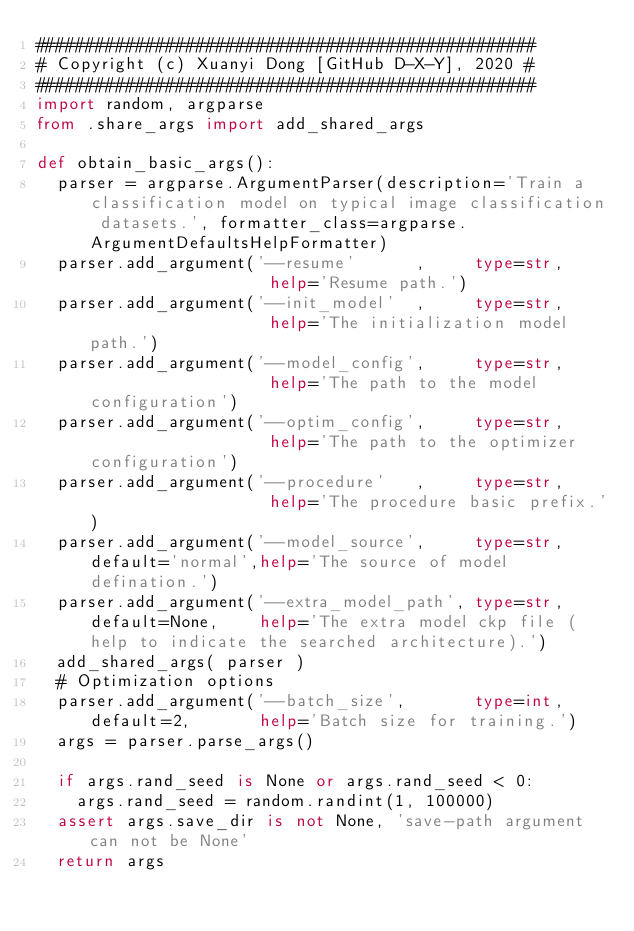Convert code to text. <code><loc_0><loc_0><loc_500><loc_500><_Python_>##################################################
# Copyright (c) Xuanyi Dong [GitHub D-X-Y], 2020 #
##################################################
import random, argparse
from .share_args import add_shared_args

def obtain_basic_args():
  parser = argparse.ArgumentParser(description='Train a classification model on typical image classification datasets.', formatter_class=argparse.ArgumentDefaultsHelpFormatter)
  parser.add_argument('--resume'      ,     type=str,                   help='Resume path.')
  parser.add_argument('--init_model'  ,     type=str,                   help='The initialization model path.')
  parser.add_argument('--model_config',     type=str,                   help='The path to the model configuration')
  parser.add_argument('--optim_config',     type=str,                   help='The path to the optimizer configuration')
  parser.add_argument('--procedure'   ,     type=str,                   help='The procedure basic prefix.')
  parser.add_argument('--model_source',     type=str,  default='normal',help='The source of model defination.')
  parser.add_argument('--extra_model_path', type=str,  default=None,    help='The extra model ckp file (help to indicate the searched architecture).')
  add_shared_args( parser )
  # Optimization options
  parser.add_argument('--batch_size',       type=int,  default=2,       help='Batch size for training.')
  args = parser.parse_args()

  if args.rand_seed is None or args.rand_seed < 0:
    args.rand_seed = random.randint(1, 100000)
  assert args.save_dir is not None, 'save-path argument can not be None'
  return args
</code> 